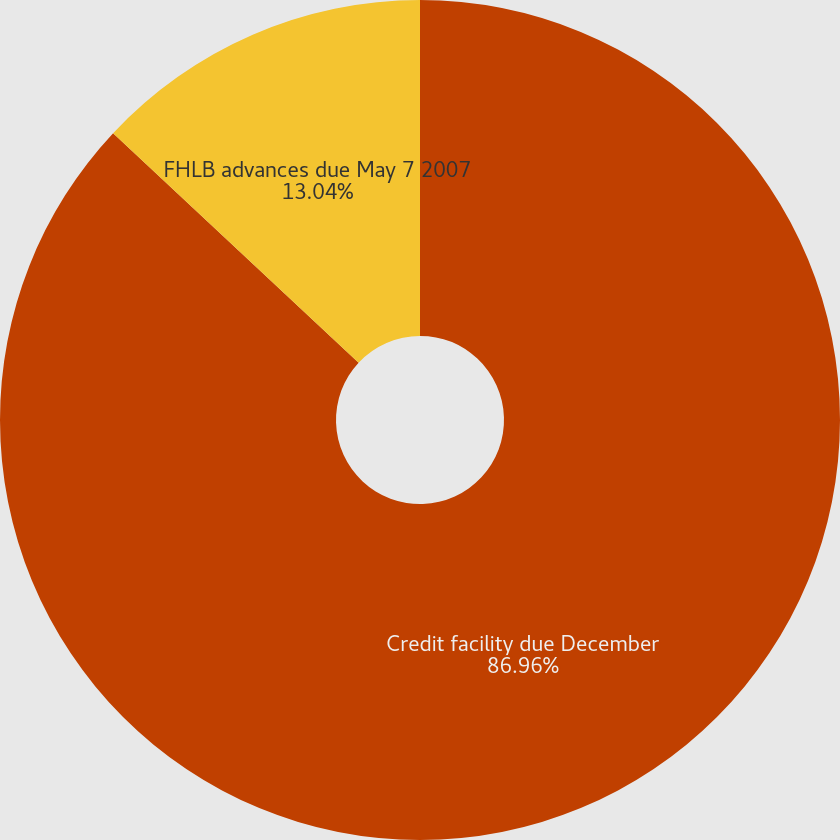Convert chart to OTSL. <chart><loc_0><loc_0><loc_500><loc_500><pie_chart><fcel>Credit facility due December<fcel>FHLB advances due May 7 2007<nl><fcel>86.96%<fcel>13.04%<nl></chart> 